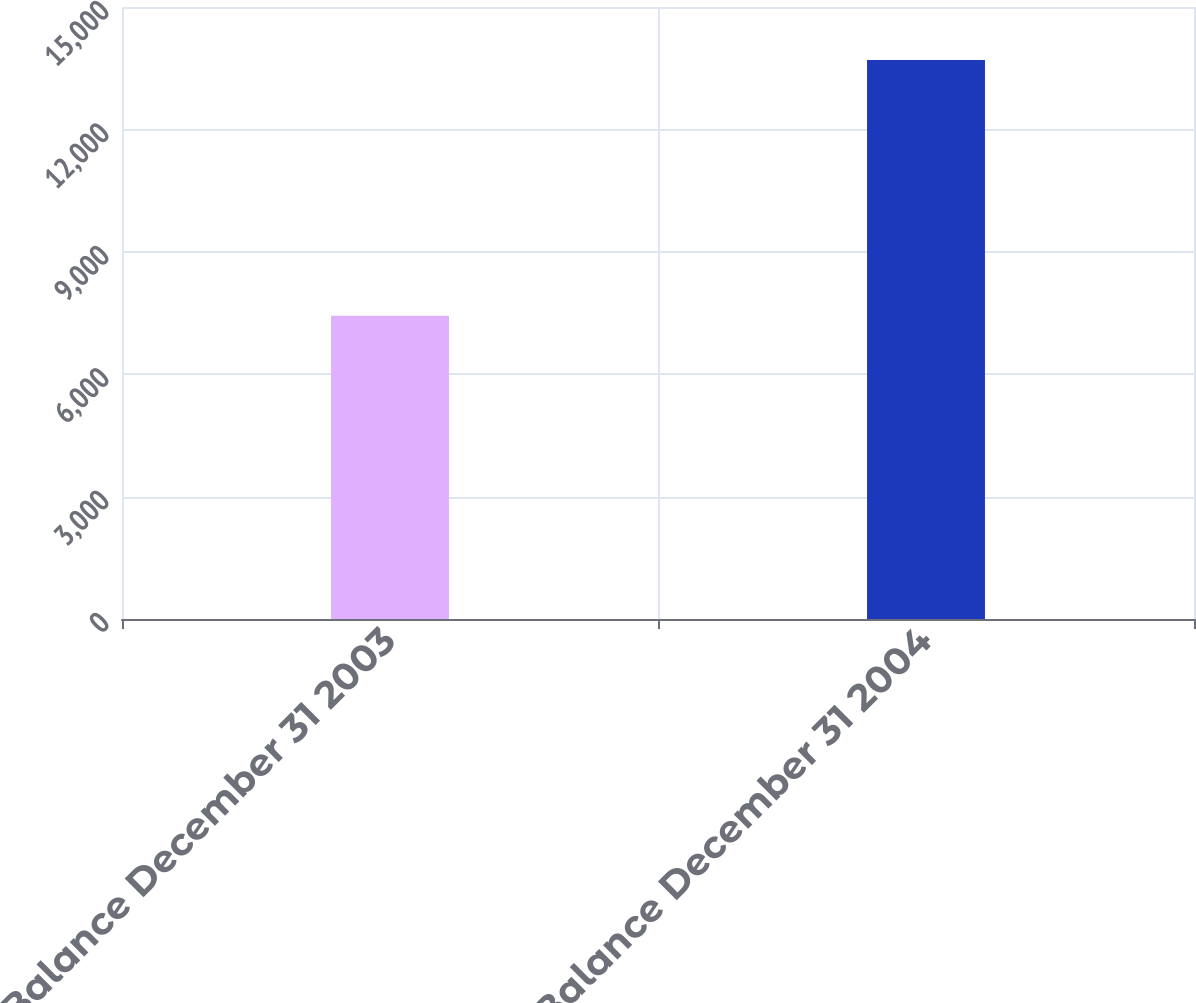<chart> <loc_0><loc_0><loc_500><loc_500><bar_chart><fcel>Balance December 31 2003<fcel>Balance December 31 2004<nl><fcel>7430<fcel>13704<nl></chart> 